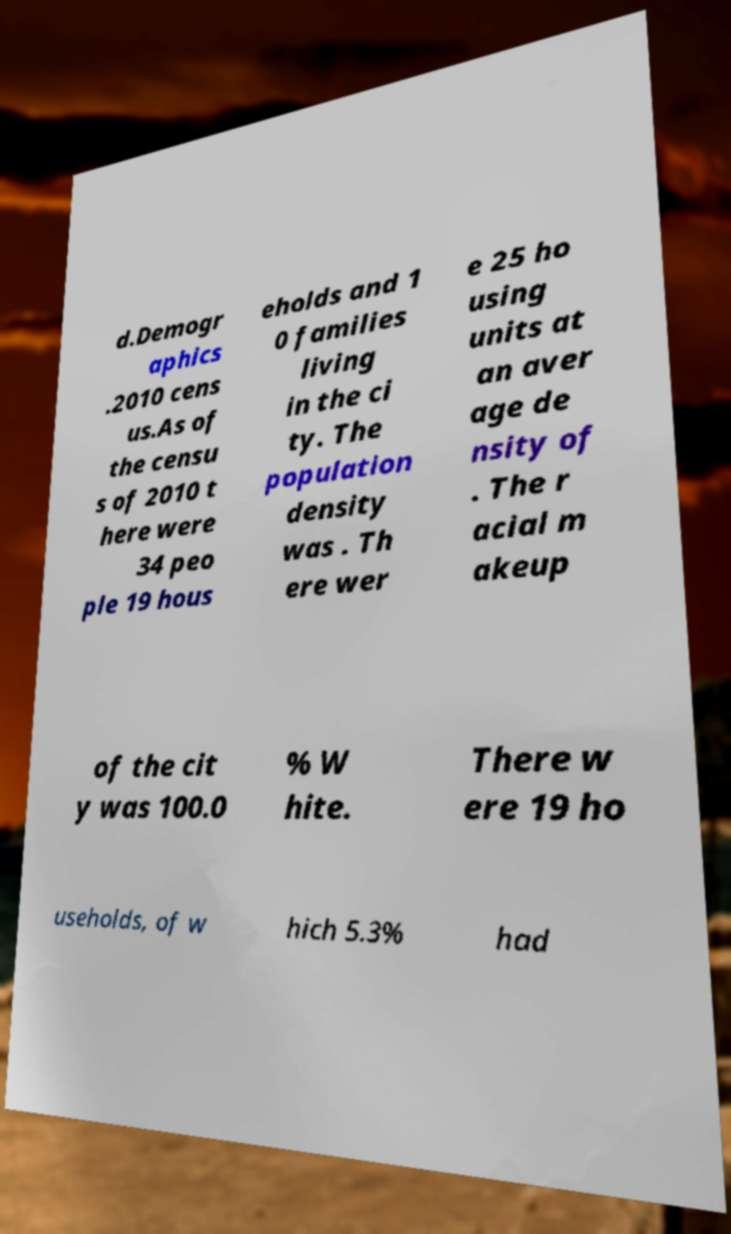Could you assist in decoding the text presented in this image and type it out clearly? d.Demogr aphics .2010 cens us.As of the censu s of 2010 t here were 34 peo ple 19 hous eholds and 1 0 families living in the ci ty. The population density was . Th ere wer e 25 ho using units at an aver age de nsity of . The r acial m akeup of the cit y was 100.0 % W hite. There w ere 19 ho useholds, of w hich 5.3% had 